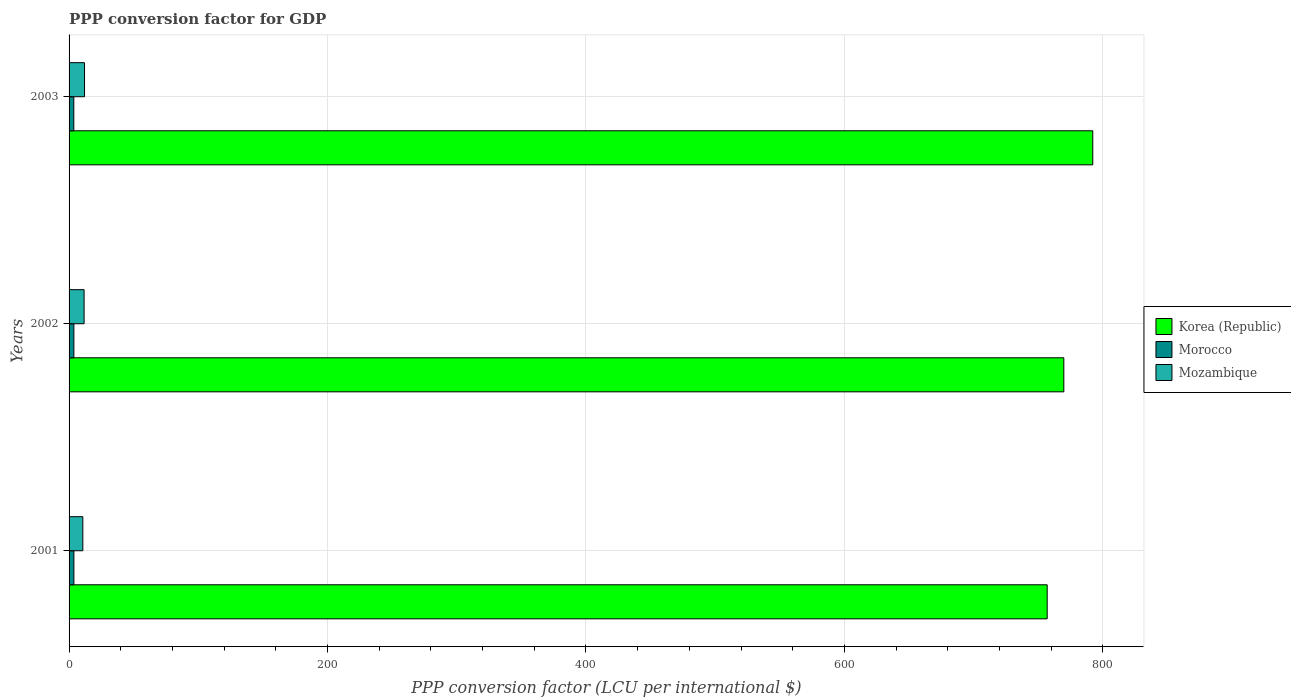How many groups of bars are there?
Give a very brief answer. 3. Are the number of bars per tick equal to the number of legend labels?
Offer a terse response. Yes. What is the PPP conversion factor for GDP in Morocco in 2001?
Ensure brevity in your answer.  3.73. Across all years, what is the maximum PPP conversion factor for GDP in Morocco?
Ensure brevity in your answer.  3.73. Across all years, what is the minimum PPP conversion factor for GDP in Mozambique?
Make the answer very short. 10.64. In which year was the PPP conversion factor for GDP in Mozambique maximum?
Offer a very short reply. 2003. What is the total PPP conversion factor for GDP in Morocco in the graph?
Your answer should be very brief. 11.12. What is the difference between the PPP conversion factor for GDP in Morocco in 2002 and that in 2003?
Make the answer very short. 0.05. What is the difference between the PPP conversion factor for GDP in Mozambique in 2001 and the PPP conversion factor for GDP in Morocco in 2003?
Provide a succinct answer. 6.97. What is the average PPP conversion factor for GDP in Morocco per year?
Provide a short and direct response. 3.71. In the year 2003, what is the difference between the PPP conversion factor for GDP in Korea (Republic) and PPP conversion factor for GDP in Mozambique?
Give a very brief answer. 780.2. In how many years, is the PPP conversion factor for GDP in Morocco greater than 40 LCU?
Provide a short and direct response. 0. What is the ratio of the PPP conversion factor for GDP in Mozambique in 2002 to that in 2003?
Make the answer very short. 0.97. Is the PPP conversion factor for GDP in Mozambique in 2002 less than that in 2003?
Your response must be concise. Yes. What is the difference between the highest and the second highest PPP conversion factor for GDP in Morocco?
Keep it short and to the point. 0.02. What is the difference between the highest and the lowest PPP conversion factor for GDP in Mozambique?
Provide a short and direct response. 1.32. In how many years, is the PPP conversion factor for GDP in Morocco greater than the average PPP conversion factor for GDP in Morocco taken over all years?
Ensure brevity in your answer.  2. What does the 2nd bar from the top in 2003 represents?
Offer a terse response. Morocco. What does the 1st bar from the bottom in 2003 represents?
Offer a very short reply. Korea (Republic). Are all the bars in the graph horizontal?
Offer a terse response. Yes. Are the values on the major ticks of X-axis written in scientific E-notation?
Give a very brief answer. No. Does the graph contain any zero values?
Make the answer very short. No. What is the title of the graph?
Your answer should be very brief. PPP conversion factor for GDP. Does "Brazil" appear as one of the legend labels in the graph?
Give a very brief answer. No. What is the label or title of the X-axis?
Offer a very short reply. PPP conversion factor (LCU per international $). What is the PPP conversion factor (LCU per international $) of Korea (Republic) in 2001?
Give a very brief answer. 756.9. What is the PPP conversion factor (LCU per international $) in Morocco in 2001?
Your answer should be compact. 3.73. What is the PPP conversion factor (LCU per international $) of Mozambique in 2001?
Keep it short and to the point. 10.64. What is the PPP conversion factor (LCU per international $) of Korea (Republic) in 2002?
Provide a short and direct response. 769.77. What is the PPP conversion factor (LCU per international $) in Morocco in 2002?
Keep it short and to the point. 3.72. What is the PPP conversion factor (LCU per international $) of Mozambique in 2002?
Offer a terse response. 11.63. What is the PPP conversion factor (LCU per international $) in Korea (Republic) in 2003?
Your answer should be compact. 792.16. What is the PPP conversion factor (LCU per international $) of Morocco in 2003?
Provide a succinct answer. 3.67. What is the PPP conversion factor (LCU per international $) in Mozambique in 2003?
Make the answer very short. 11.96. Across all years, what is the maximum PPP conversion factor (LCU per international $) of Korea (Republic)?
Ensure brevity in your answer.  792.16. Across all years, what is the maximum PPP conversion factor (LCU per international $) in Morocco?
Make the answer very short. 3.73. Across all years, what is the maximum PPP conversion factor (LCU per international $) in Mozambique?
Offer a terse response. 11.96. Across all years, what is the minimum PPP conversion factor (LCU per international $) of Korea (Republic)?
Your answer should be compact. 756.9. Across all years, what is the minimum PPP conversion factor (LCU per international $) in Morocco?
Your answer should be very brief. 3.67. Across all years, what is the minimum PPP conversion factor (LCU per international $) of Mozambique?
Your answer should be compact. 10.64. What is the total PPP conversion factor (LCU per international $) in Korea (Republic) in the graph?
Provide a succinct answer. 2318.83. What is the total PPP conversion factor (LCU per international $) of Morocco in the graph?
Make the answer very short. 11.12. What is the total PPP conversion factor (LCU per international $) of Mozambique in the graph?
Keep it short and to the point. 34.24. What is the difference between the PPP conversion factor (LCU per international $) in Korea (Republic) in 2001 and that in 2002?
Keep it short and to the point. -12.87. What is the difference between the PPP conversion factor (LCU per international $) of Morocco in 2001 and that in 2002?
Your answer should be very brief. 0.02. What is the difference between the PPP conversion factor (LCU per international $) in Mozambique in 2001 and that in 2002?
Provide a succinct answer. -0.99. What is the difference between the PPP conversion factor (LCU per international $) in Korea (Republic) in 2001 and that in 2003?
Your answer should be compact. -35.26. What is the difference between the PPP conversion factor (LCU per international $) of Morocco in 2001 and that in 2003?
Your response must be concise. 0.06. What is the difference between the PPP conversion factor (LCU per international $) in Mozambique in 2001 and that in 2003?
Make the answer very short. -1.32. What is the difference between the PPP conversion factor (LCU per international $) in Korea (Republic) in 2002 and that in 2003?
Make the answer very short. -22.39. What is the difference between the PPP conversion factor (LCU per international $) of Morocco in 2002 and that in 2003?
Make the answer very short. 0.05. What is the difference between the PPP conversion factor (LCU per international $) of Mozambique in 2002 and that in 2003?
Provide a succinct answer. -0.33. What is the difference between the PPP conversion factor (LCU per international $) in Korea (Republic) in 2001 and the PPP conversion factor (LCU per international $) in Morocco in 2002?
Keep it short and to the point. 753.18. What is the difference between the PPP conversion factor (LCU per international $) of Korea (Republic) in 2001 and the PPP conversion factor (LCU per international $) of Mozambique in 2002?
Ensure brevity in your answer.  745.27. What is the difference between the PPP conversion factor (LCU per international $) in Morocco in 2001 and the PPP conversion factor (LCU per international $) in Mozambique in 2002?
Offer a terse response. -7.9. What is the difference between the PPP conversion factor (LCU per international $) of Korea (Republic) in 2001 and the PPP conversion factor (LCU per international $) of Morocco in 2003?
Keep it short and to the point. 753.23. What is the difference between the PPP conversion factor (LCU per international $) in Korea (Republic) in 2001 and the PPP conversion factor (LCU per international $) in Mozambique in 2003?
Give a very brief answer. 744.93. What is the difference between the PPP conversion factor (LCU per international $) of Morocco in 2001 and the PPP conversion factor (LCU per international $) of Mozambique in 2003?
Keep it short and to the point. -8.23. What is the difference between the PPP conversion factor (LCU per international $) of Korea (Republic) in 2002 and the PPP conversion factor (LCU per international $) of Morocco in 2003?
Offer a very short reply. 766.1. What is the difference between the PPP conversion factor (LCU per international $) in Korea (Republic) in 2002 and the PPP conversion factor (LCU per international $) in Mozambique in 2003?
Offer a very short reply. 757.81. What is the difference between the PPP conversion factor (LCU per international $) of Morocco in 2002 and the PPP conversion factor (LCU per international $) of Mozambique in 2003?
Ensure brevity in your answer.  -8.25. What is the average PPP conversion factor (LCU per international $) in Korea (Republic) per year?
Your answer should be very brief. 772.94. What is the average PPP conversion factor (LCU per international $) of Morocco per year?
Your answer should be compact. 3.71. What is the average PPP conversion factor (LCU per international $) of Mozambique per year?
Your answer should be compact. 11.41. In the year 2001, what is the difference between the PPP conversion factor (LCU per international $) of Korea (Republic) and PPP conversion factor (LCU per international $) of Morocco?
Give a very brief answer. 753.17. In the year 2001, what is the difference between the PPP conversion factor (LCU per international $) of Korea (Republic) and PPP conversion factor (LCU per international $) of Mozambique?
Your response must be concise. 746.26. In the year 2001, what is the difference between the PPP conversion factor (LCU per international $) of Morocco and PPP conversion factor (LCU per international $) of Mozambique?
Offer a very short reply. -6.91. In the year 2002, what is the difference between the PPP conversion factor (LCU per international $) of Korea (Republic) and PPP conversion factor (LCU per international $) of Morocco?
Keep it short and to the point. 766.05. In the year 2002, what is the difference between the PPP conversion factor (LCU per international $) of Korea (Republic) and PPP conversion factor (LCU per international $) of Mozambique?
Offer a terse response. 758.14. In the year 2002, what is the difference between the PPP conversion factor (LCU per international $) in Morocco and PPP conversion factor (LCU per international $) in Mozambique?
Ensure brevity in your answer.  -7.91. In the year 2003, what is the difference between the PPP conversion factor (LCU per international $) in Korea (Republic) and PPP conversion factor (LCU per international $) in Morocco?
Offer a very short reply. 788.49. In the year 2003, what is the difference between the PPP conversion factor (LCU per international $) of Korea (Republic) and PPP conversion factor (LCU per international $) of Mozambique?
Ensure brevity in your answer.  780.2. In the year 2003, what is the difference between the PPP conversion factor (LCU per international $) in Morocco and PPP conversion factor (LCU per international $) in Mozambique?
Ensure brevity in your answer.  -8.29. What is the ratio of the PPP conversion factor (LCU per international $) in Korea (Republic) in 2001 to that in 2002?
Your response must be concise. 0.98. What is the ratio of the PPP conversion factor (LCU per international $) in Morocco in 2001 to that in 2002?
Give a very brief answer. 1. What is the ratio of the PPP conversion factor (LCU per international $) in Mozambique in 2001 to that in 2002?
Offer a terse response. 0.92. What is the ratio of the PPP conversion factor (LCU per international $) of Korea (Republic) in 2001 to that in 2003?
Your answer should be very brief. 0.96. What is the ratio of the PPP conversion factor (LCU per international $) of Morocco in 2001 to that in 2003?
Keep it short and to the point. 1.02. What is the ratio of the PPP conversion factor (LCU per international $) in Mozambique in 2001 to that in 2003?
Make the answer very short. 0.89. What is the ratio of the PPP conversion factor (LCU per international $) of Korea (Republic) in 2002 to that in 2003?
Give a very brief answer. 0.97. What is the ratio of the PPP conversion factor (LCU per international $) in Morocco in 2002 to that in 2003?
Provide a short and direct response. 1.01. What is the ratio of the PPP conversion factor (LCU per international $) of Mozambique in 2002 to that in 2003?
Your response must be concise. 0.97. What is the difference between the highest and the second highest PPP conversion factor (LCU per international $) of Korea (Republic)?
Ensure brevity in your answer.  22.39. What is the difference between the highest and the second highest PPP conversion factor (LCU per international $) of Morocco?
Your response must be concise. 0.02. What is the difference between the highest and the second highest PPP conversion factor (LCU per international $) in Mozambique?
Offer a very short reply. 0.33. What is the difference between the highest and the lowest PPP conversion factor (LCU per international $) of Korea (Republic)?
Provide a short and direct response. 35.26. What is the difference between the highest and the lowest PPP conversion factor (LCU per international $) in Morocco?
Keep it short and to the point. 0.06. What is the difference between the highest and the lowest PPP conversion factor (LCU per international $) of Mozambique?
Your response must be concise. 1.32. 